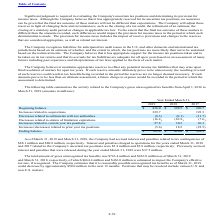According to Microchip Technology's financial document, What was the total amount of gross unrecognized tax benefits in 2019? According to the financial document, 763.4 (in millions). The relevant text states: "Ending balance $ 763.4 $ 436.0 $ 398.5..." Also, What was the company's accrued interest and penalties related to tax contingencies in 2018? According to the financial document, 80.8 (in millions). The relevant text states: "$88.1 million and $80.8 million, respectively. Interest and penalties charged to operations for the years ended March 31, 2..." Also, What were the Increases related to acquisitions in 2017? According to the financial document, 193.3 (in millions). The relevant text states: "Increases related to acquisitions 329.7 — 193.3..." Also, can you calculate: What was the change in the Beginning balance between 2017 and 2018? Based on the calculation: 398.5-220.7, the result is 177.8 (in millions). This is based on the information: "Beginning balance $ 436.0 $ 398.5 $ 220.7 Beginning balance $ 436.0 $ 398.5 $ 220.7..." The key data points involved are: 220.7, 398.5. Also, How many years did Increases related to current year tax positions exceed $30 million? Based on the analysis, there are 1 instances. The counting process: 2018. Also, can you calculate: What was the percentage change in the Ending balance between 2018 and 2019? To answer this question, I need to perform calculations using the financial data. The calculation is: (763.4-436.0)/436.0, which equals 75.09 (percentage). This is based on the information: "Beginning balance $ 436.0 $ 398.5 $ 220.7 Ending balance $ 763.4 $ 436.0 $ 398.5..." The key data points involved are: 436.0, 763.4. 